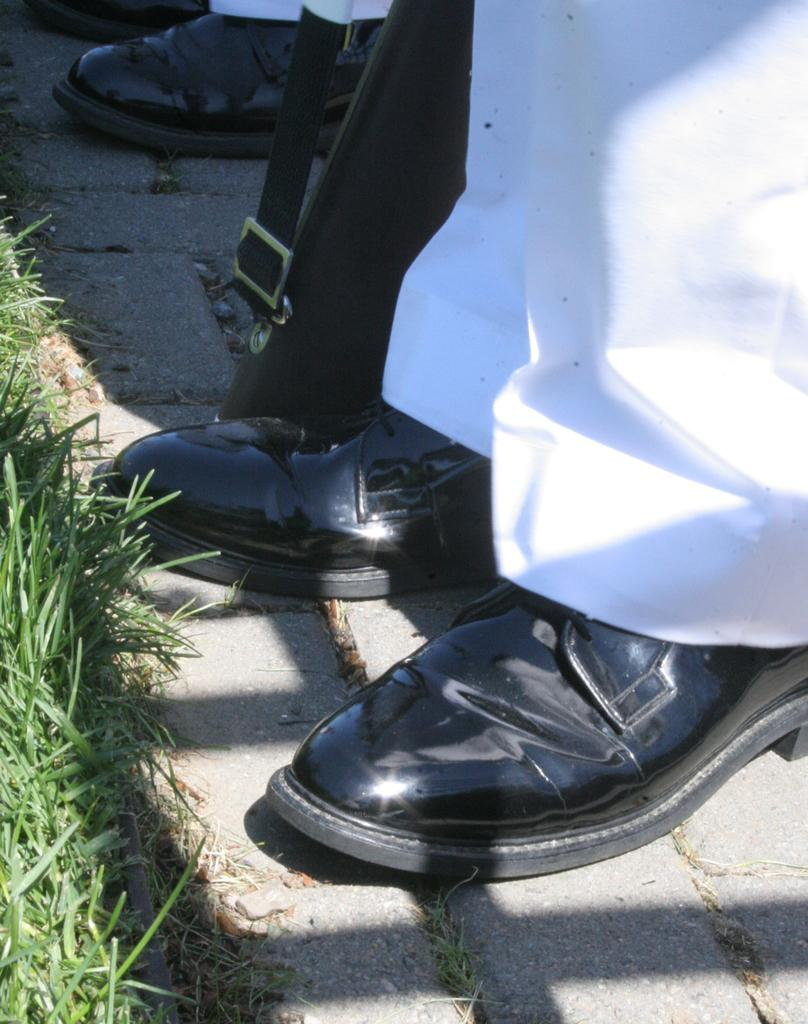What type of vegetation is present in the image? There is grass in the image. Can you describe any human elements in the image? Yes, there are legs of people visible in the image. What can be seen on the ground in the image? Shoes are present on the ground in the image. What type of quartz can be seen in the image? There is no quartz present in the image. Is there a hat visible in the image? There is no hat visible in the image. 